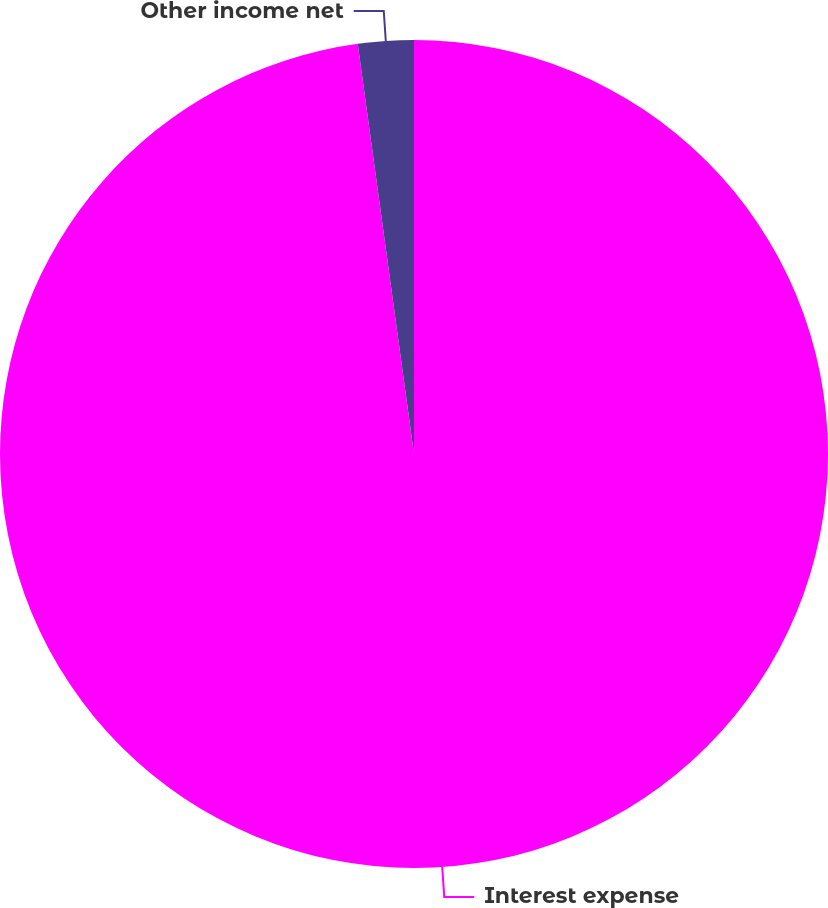Convert chart. <chart><loc_0><loc_0><loc_500><loc_500><pie_chart><fcel>Interest expense<fcel>Other income net<nl><fcel>97.83%<fcel>2.17%<nl></chart> 